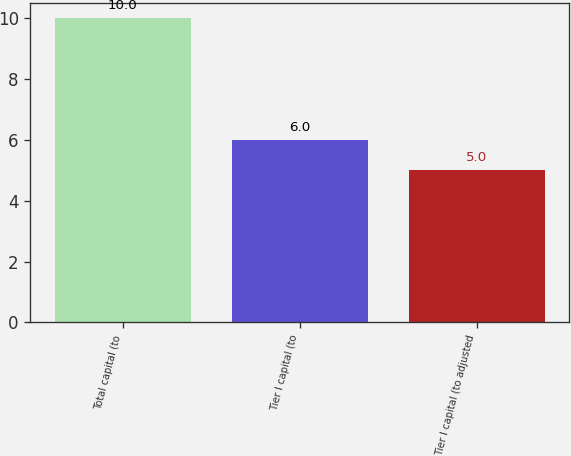Convert chart to OTSL. <chart><loc_0><loc_0><loc_500><loc_500><bar_chart><fcel>Total capital (to<fcel>Tier I capital (to<fcel>Tier I capital (to adjusted<nl><fcel>10<fcel>6<fcel>5<nl></chart> 